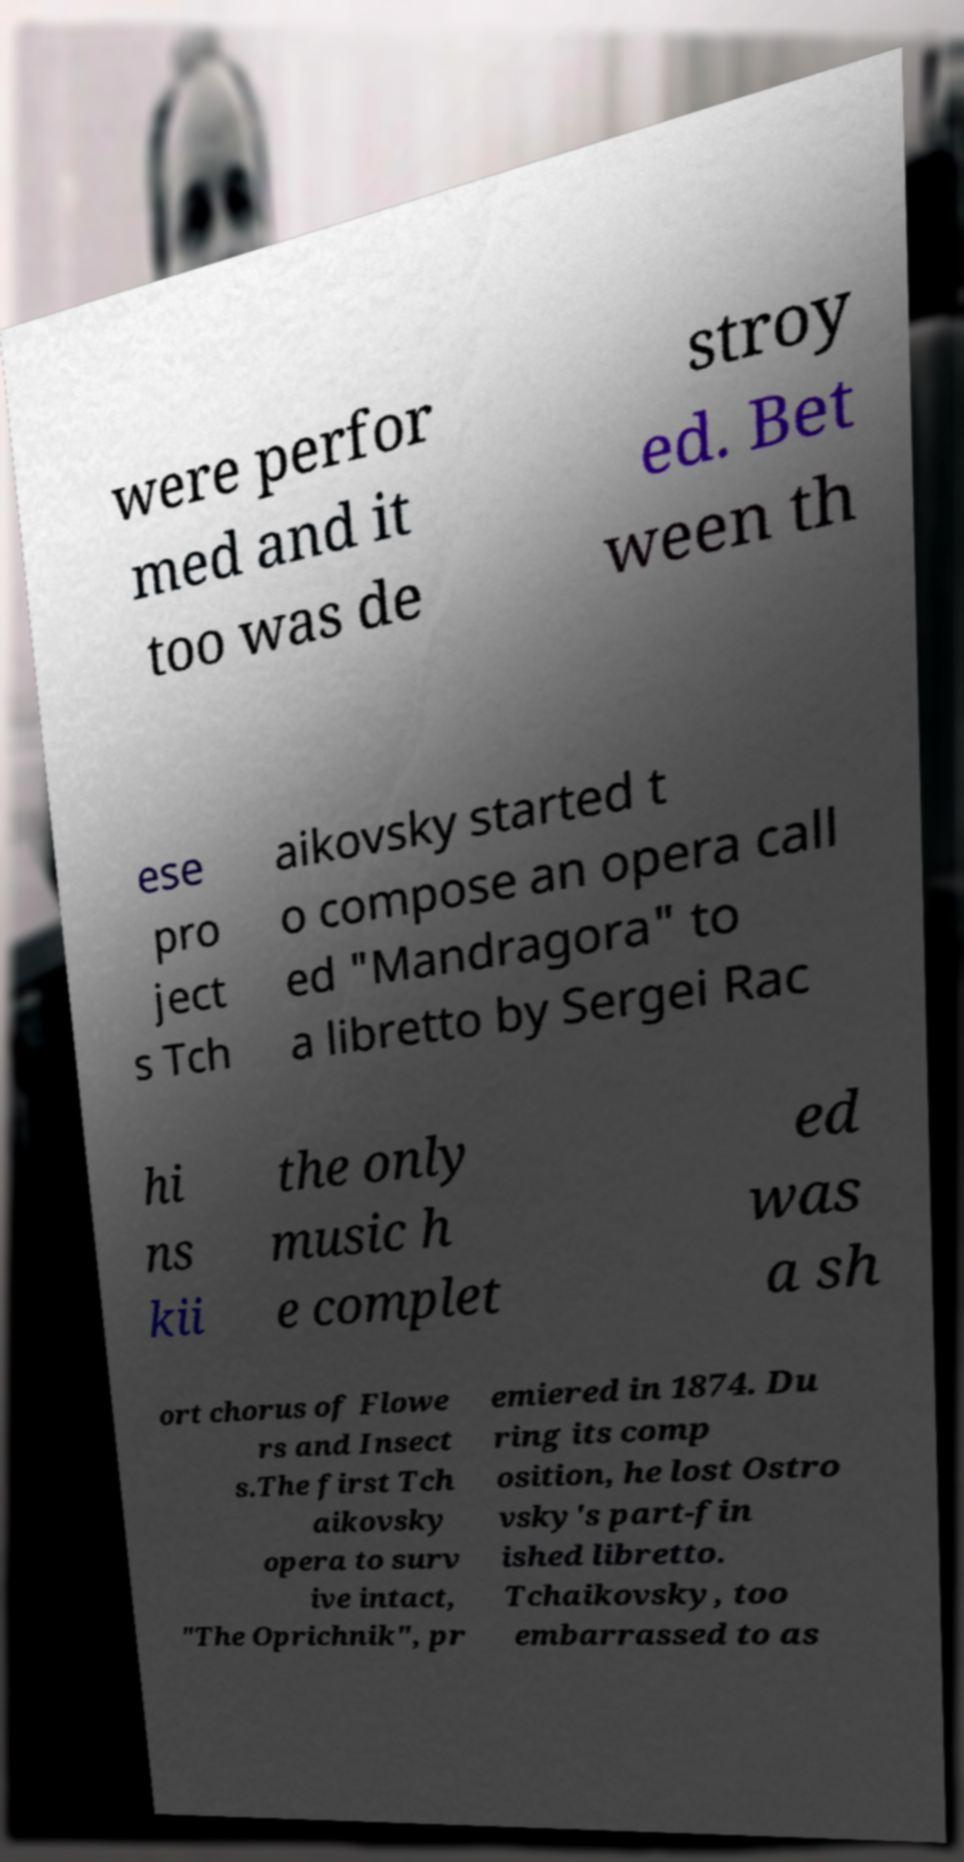Could you assist in decoding the text presented in this image and type it out clearly? were perfor med and it too was de stroy ed. Bet ween th ese pro ject s Tch aikovsky started t o compose an opera call ed "Mandragora" to a libretto by Sergei Rac hi ns kii the only music h e complet ed was a sh ort chorus of Flowe rs and Insect s.The first Tch aikovsky opera to surv ive intact, "The Oprichnik", pr emiered in 1874. Du ring its comp osition, he lost Ostro vsky's part-fin ished libretto. Tchaikovsky, too embarrassed to as 